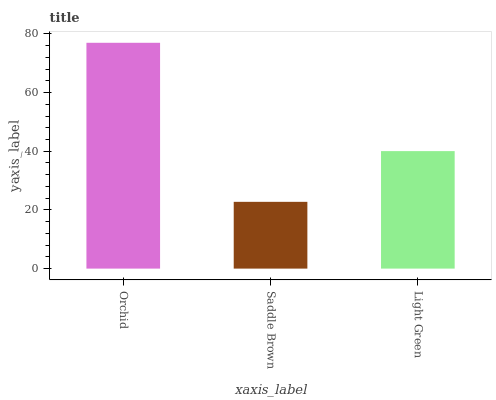Is Light Green the minimum?
Answer yes or no. No. Is Light Green the maximum?
Answer yes or no. No. Is Light Green greater than Saddle Brown?
Answer yes or no. Yes. Is Saddle Brown less than Light Green?
Answer yes or no. Yes. Is Saddle Brown greater than Light Green?
Answer yes or no. No. Is Light Green less than Saddle Brown?
Answer yes or no. No. Is Light Green the high median?
Answer yes or no. Yes. Is Light Green the low median?
Answer yes or no. Yes. Is Saddle Brown the high median?
Answer yes or no. No. Is Saddle Brown the low median?
Answer yes or no. No. 